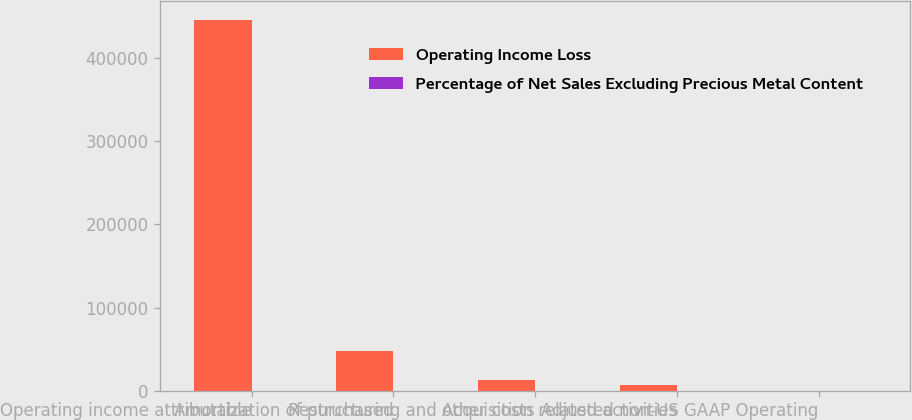Convert chart. <chart><loc_0><loc_0><loc_500><loc_500><stacked_bar_chart><ecel><fcel>Operating income attributable<fcel>Amortization of purchased<fcel>Restructuring and other costs<fcel>Acquisition related activities<fcel>Adjusted non-US GAAP Operating<nl><fcel>Operating Income Loss<fcel>445600<fcel>47914<fcel>12463<fcel>6827<fcel>18.4<nl><fcel>Percentage of Net Sales Excluding Precious Metal Content<fcel>16<fcel>1.8<fcel>0.4<fcel>0.2<fcel>18.4<nl></chart> 